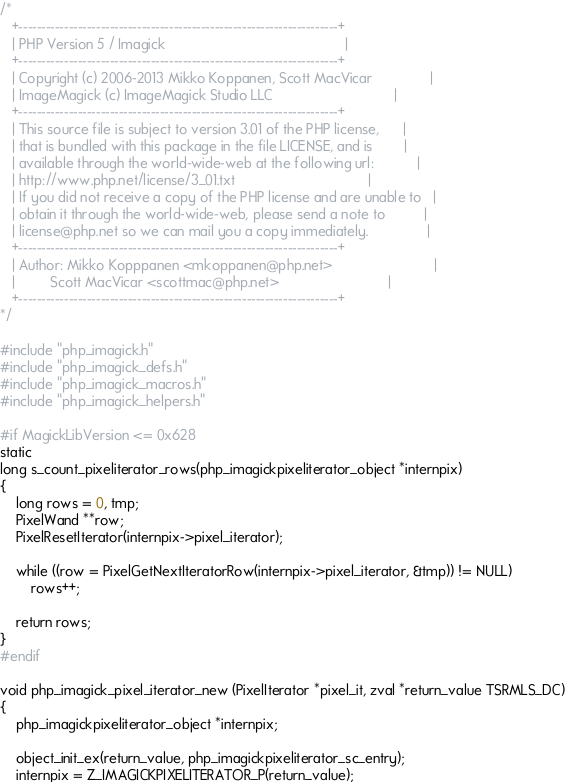Convert code to text. <code><loc_0><loc_0><loc_500><loc_500><_C_>/*
   +----------------------------------------------------------------------+
   | PHP Version 5 / Imagick	                                          |
   +----------------------------------------------------------------------+
   | Copyright (c) 2006-2013 Mikko Koppanen, Scott MacVicar               |
   | ImageMagick (c) ImageMagick Studio LLC                               |
   +----------------------------------------------------------------------+
   | This source file is subject to version 3.01 of the PHP license,      |
   | that is bundled with this package in the file LICENSE, and is        |
   | available through the world-wide-web at the following url:           |
   | http://www.php.net/license/3_01.txt                                  |
   | If you did not receive a copy of the PHP license and are unable to   |
   | obtain it through the world-wide-web, please send a note to          |
   | license@php.net so we can mail you a copy immediately.               |
   +----------------------------------------------------------------------+
   | Author: Mikko Kopppanen <mkoppanen@php.net>                          |
   |         Scott MacVicar <scottmac@php.net>                            |
   +----------------------------------------------------------------------+
*/

#include "php_imagick.h"
#include "php_imagick_defs.h"
#include "php_imagick_macros.h"
#include "php_imagick_helpers.h"

#if MagickLibVersion <= 0x628
static
long s_count_pixeliterator_rows(php_imagickpixeliterator_object *internpix)
{
	long rows = 0, tmp;
	PixelWand **row;
	PixelResetIterator(internpix->pixel_iterator);

	while ((row = PixelGetNextIteratorRow(internpix->pixel_iterator, &tmp)) != NULL)
		rows++;

	return rows;
}
#endif

void php_imagick_pixel_iterator_new (PixelIterator *pixel_it, zval *return_value TSRMLS_DC)
{
	php_imagickpixeliterator_object *internpix;

	object_init_ex(return_value, php_imagickpixeliterator_sc_entry);
	internpix = Z_IMAGICKPIXELITERATOR_P(return_value);
</code> 